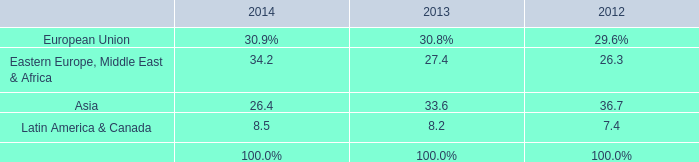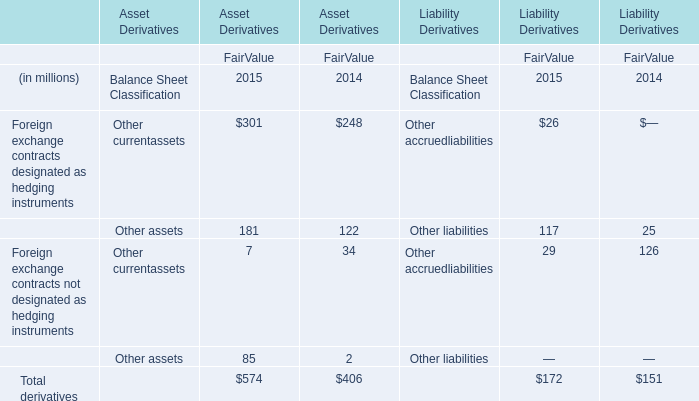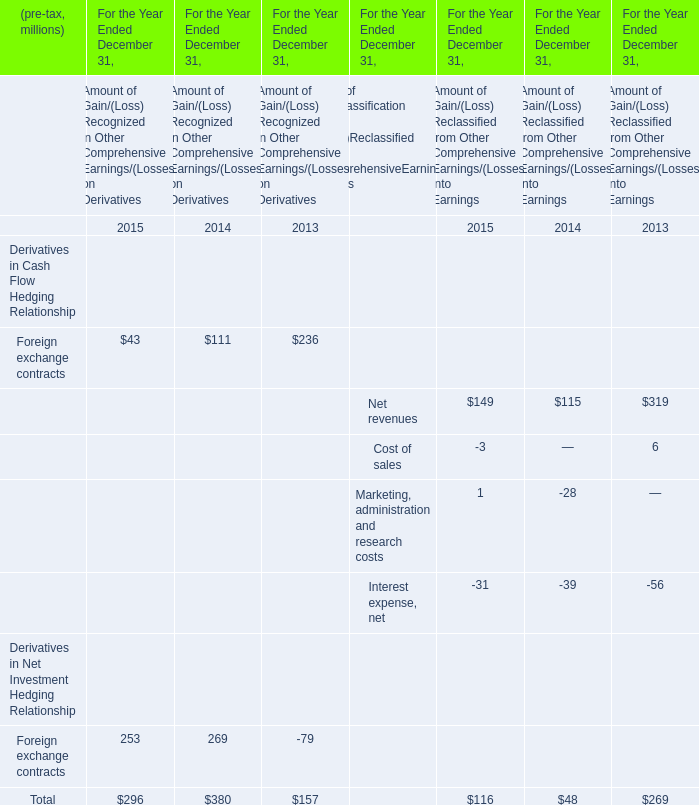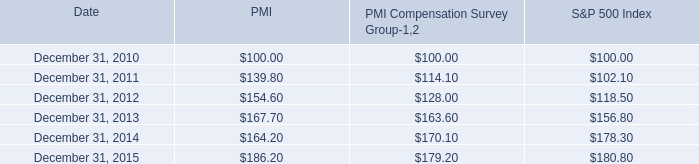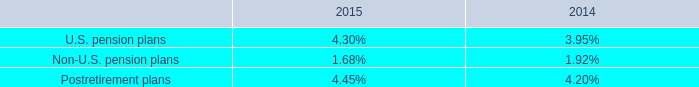When does Foreign exchange contracts reach the largest value? 
Answer: 2013. 